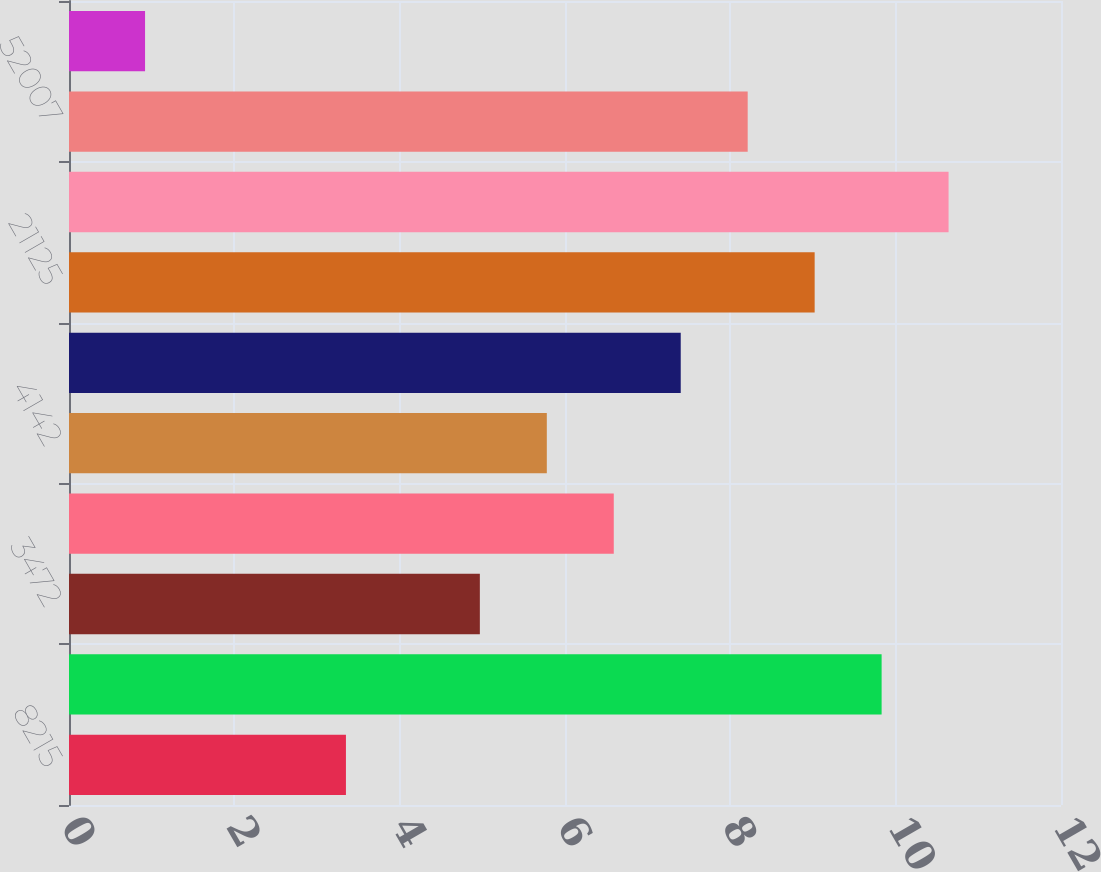<chart> <loc_0><loc_0><loc_500><loc_500><bar_chart><fcel>8215<fcel>609<fcel>3472<fcel>61<fcel>4142<fcel>128<fcel>21125<fcel>10337<fcel>52007<fcel>23532<nl><fcel>3.35<fcel>9.83<fcel>4.97<fcel>6.59<fcel>5.78<fcel>7.4<fcel>9.02<fcel>10.64<fcel>8.21<fcel>0.92<nl></chart> 